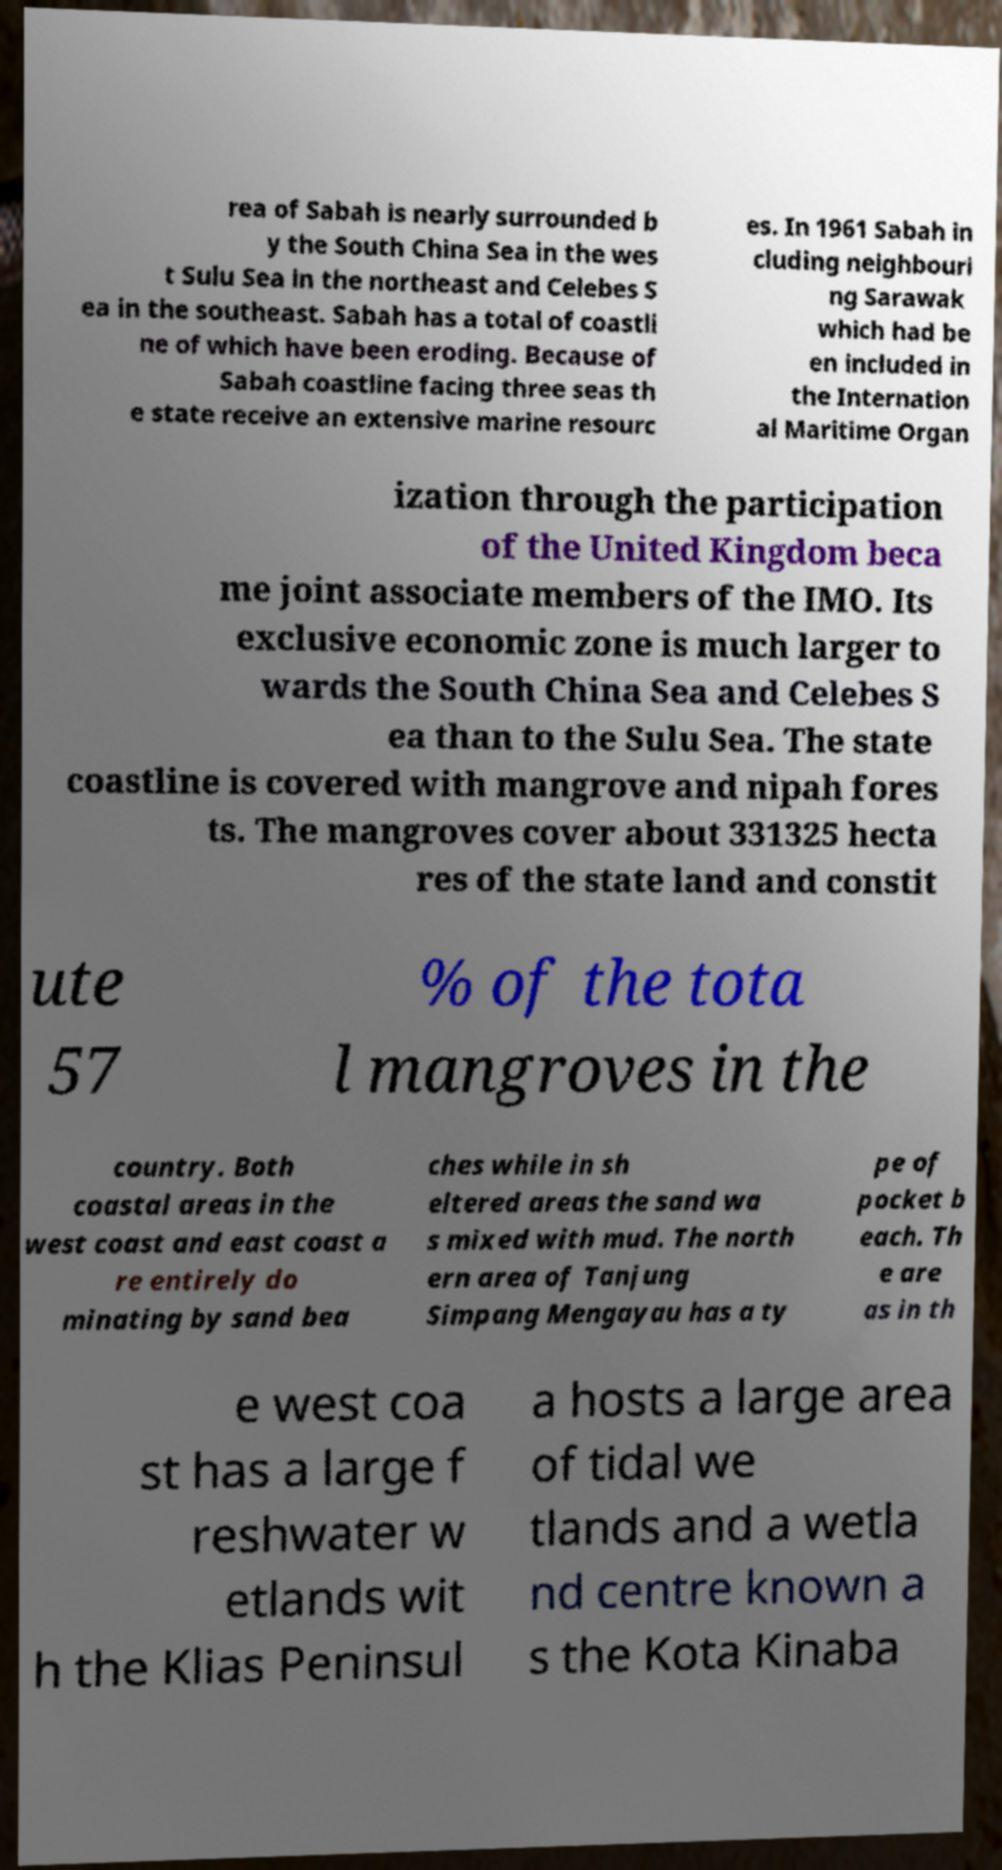For documentation purposes, I need the text within this image transcribed. Could you provide that? rea of Sabah is nearly surrounded b y the South China Sea in the wes t Sulu Sea in the northeast and Celebes S ea in the southeast. Sabah has a total of coastli ne of which have been eroding. Because of Sabah coastline facing three seas th e state receive an extensive marine resourc es. In 1961 Sabah in cluding neighbouri ng Sarawak which had be en included in the Internation al Maritime Organ ization through the participation of the United Kingdom beca me joint associate members of the IMO. Its exclusive economic zone is much larger to wards the South China Sea and Celebes S ea than to the Sulu Sea. The state coastline is covered with mangrove and nipah fores ts. The mangroves cover about 331325 hecta res of the state land and constit ute 57 % of the tota l mangroves in the country. Both coastal areas in the west coast and east coast a re entirely do minating by sand bea ches while in sh eltered areas the sand wa s mixed with mud. The north ern area of Tanjung Simpang Mengayau has a ty pe of pocket b each. Th e are as in th e west coa st has a large f reshwater w etlands wit h the Klias Peninsul a hosts a large area of tidal we tlands and a wetla nd centre known a s the Kota Kinaba 